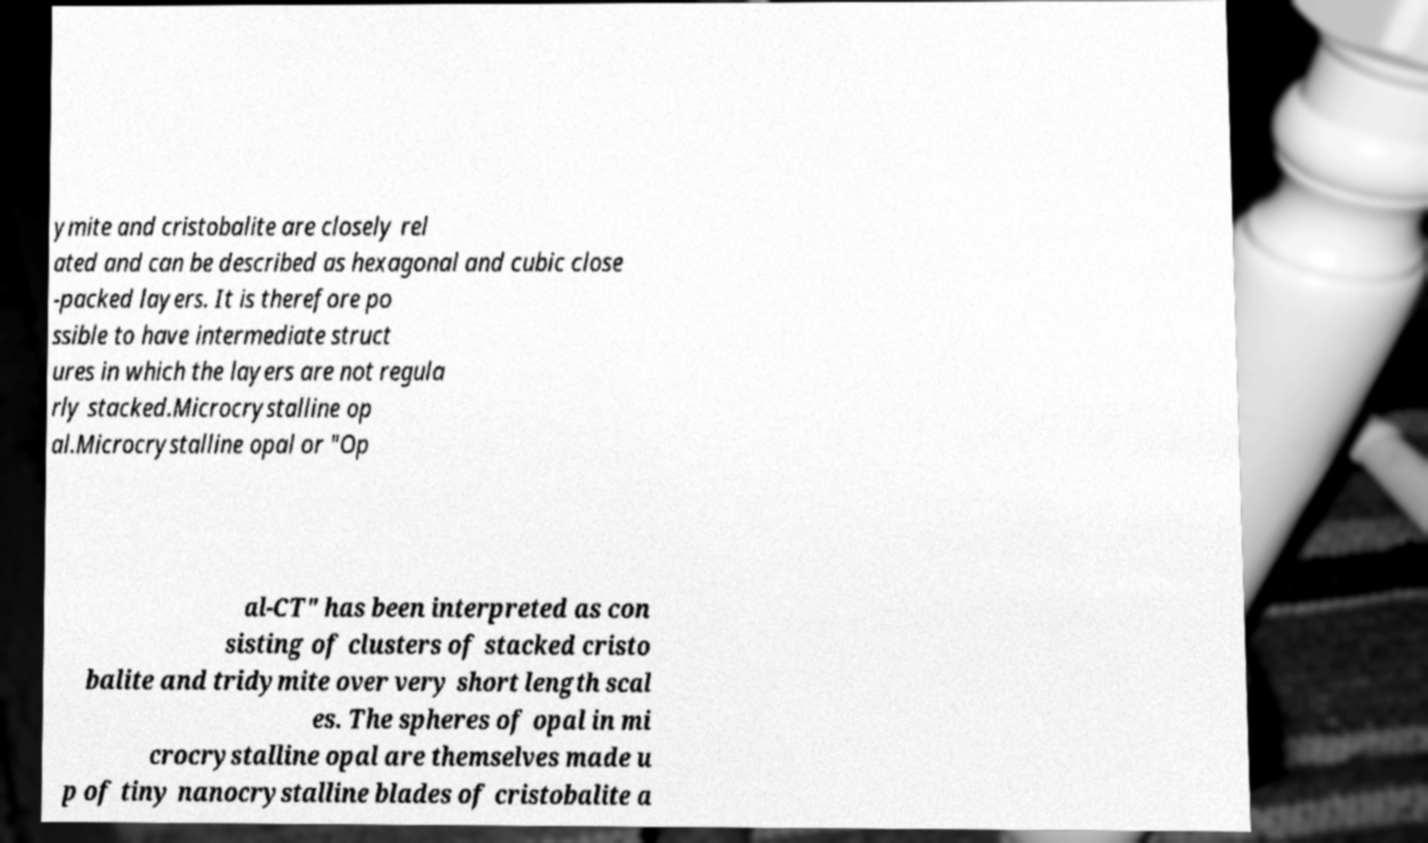What messages or text are displayed in this image? I need them in a readable, typed format. ymite and cristobalite are closely rel ated and can be described as hexagonal and cubic close -packed layers. It is therefore po ssible to have intermediate struct ures in which the layers are not regula rly stacked.Microcrystalline op al.Microcrystalline opal or "Op al-CT" has been interpreted as con sisting of clusters of stacked cristo balite and tridymite over very short length scal es. The spheres of opal in mi crocrystalline opal are themselves made u p of tiny nanocrystalline blades of cristobalite a 